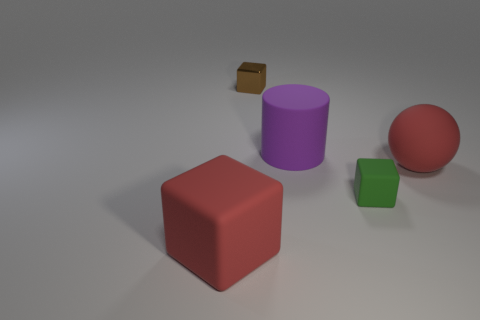There is a rubber thing that is the same color as the large sphere; what is its size?
Offer a very short reply. Large. There is a red object on the left side of the purple rubber thing; what shape is it?
Provide a short and direct response. Cube. Do the purple cylinder and the small thing that is to the right of the big purple cylinder have the same material?
Your response must be concise. Yes. Do the green thing and the brown thing have the same shape?
Keep it short and to the point. Yes. There is a tiny green object that is the same shape as the small brown metal thing; what is it made of?
Ensure brevity in your answer.  Rubber. The thing that is behind the red ball and in front of the brown object is what color?
Make the answer very short. Purple. What color is the rubber ball?
Your answer should be very brief. Red. There is a object that is the same color as the ball; what is its material?
Offer a terse response. Rubber. Is there a purple matte object of the same shape as the brown metal object?
Offer a very short reply. No. How big is the red thing behind the small green block?
Make the answer very short. Large. 